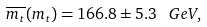Convert formula to latex. <formula><loc_0><loc_0><loc_500><loc_500>\overline { m _ { t } } ( m _ { t } ) = 1 6 6 . 8 \pm 5 . 3 \, \ G e V ,</formula> 